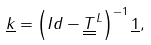Convert formula to latex. <formula><loc_0><loc_0><loc_500><loc_500>\underline { k } = \left ( I d - \underline { \underline { T } } ^ { L } \right ) ^ { - 1 } \underline { 1 } ,</formula> 